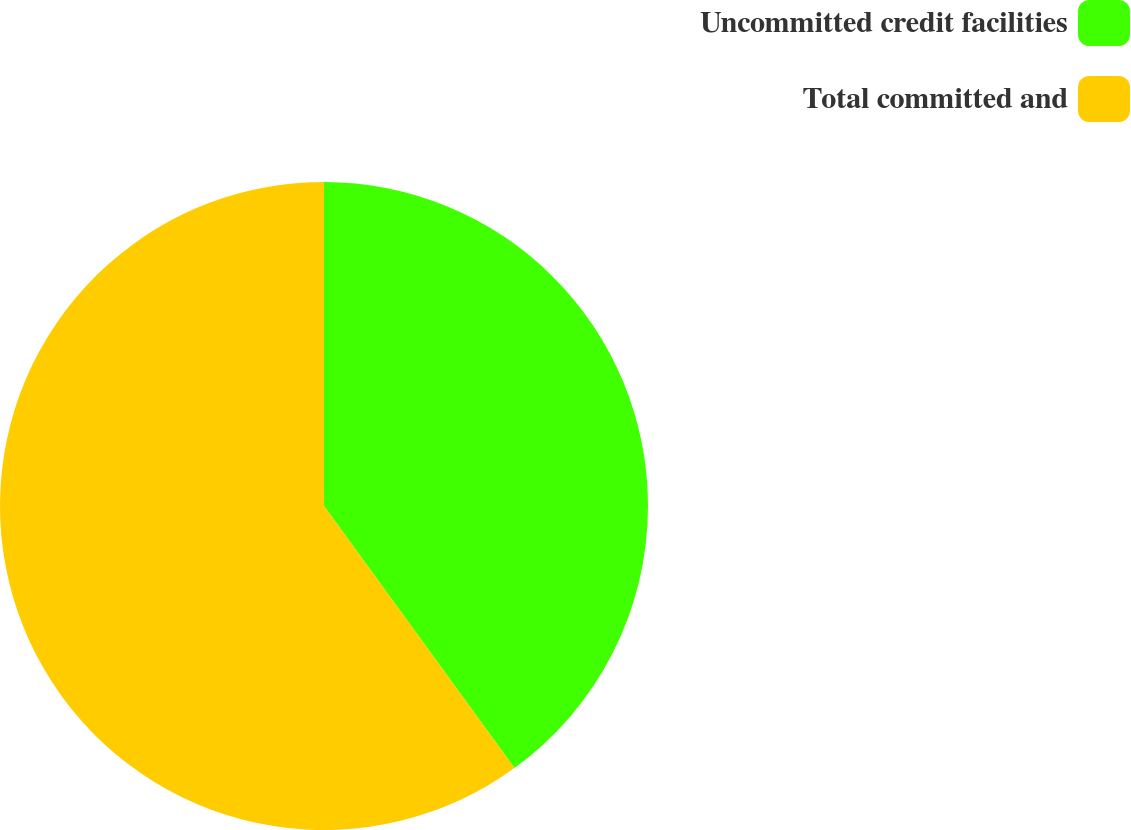Convert chart to OTSL. <chart><loc_0><loc_0><loc_500><loc_500><pie_chart><fcel>Uncommitted credit facilities<fcel>Total committed and<nl><fcel>40.0%<fcel>60.0%<nl></chart> 